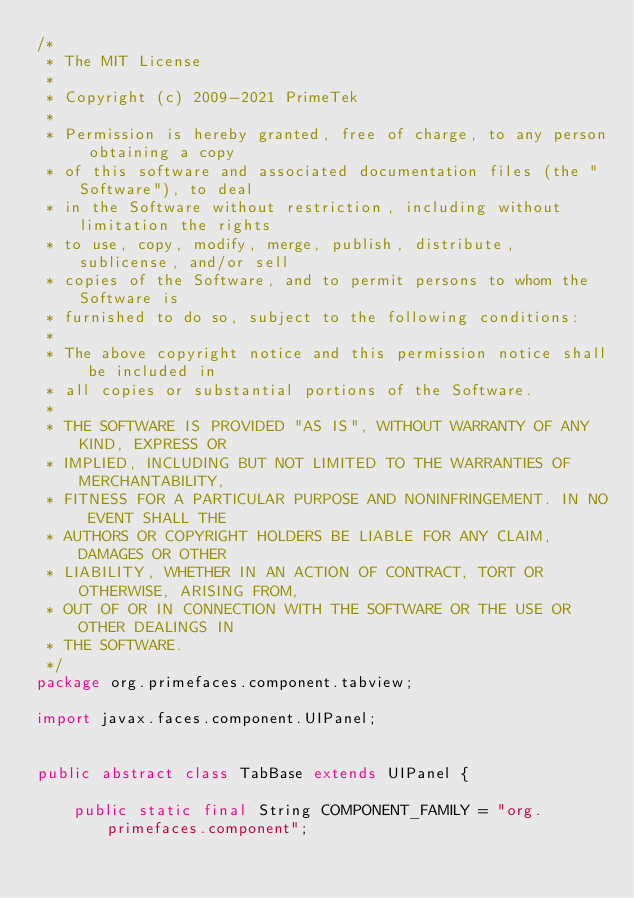<code> <loc_0><loc_0><loc_500><loc_500><_Java_>/*
 * The MIT License
 *
 * Copyright (c) 2009-2021 PrimeTek
 *
 * Permission is hereby granted, free of charge, to any person obtaining a copy
 * of this software and associated documentation files (the "Software"), to deal
 * in the Software without restriction, including without limitation the rights
 * to use, copy, modify, merge, publish, distribute, sublicense, and/or sell
 * copies of the Software, and to permit persons to whom the Software is
 * furnished to do so, subject to the following conditions:
 *
 * The above copyright notice and this permission notice shall be included in
 * all copies or substantial portions of the Software.
 *
 * THE SOFTWARE IS PROVIDED "AS IS", WITHOUT WARRANTY OF ANY KIND, EXPRESS OR
 * IMPLIED, INCLUDING BUT NOT LIMITED TO THE WARRANTIES OF MERCHANTABILITY,
 * FITNESS FOR A PARTICULAR PURPOSE AND NONINFRINGEMENT. IN NO EVENT SHALL THE
 * AUTHORS OR COPYRIGHT HOLDERS BE LIABLE FOR ANY CLAIM, DAMAGES OR OTHER
 * LIABILITY, WHETHER IN AN ACTION OF CONTRACT, TORT OR OTHERWISE, ARISING FROM,
 * OUT OF OR IN CONNECTION WITH THE SOFTWARE OR THE USE OR OTHER DEALINGS IN
 * THE SOFTWARE.
 */
package org.primefaces.component.tabview;

import javax.faces.component.UIPanel;


public abstract class TabBase extends UIPanel {

    public static final String COMPONENT_FAMILY = "org.primefaces.component";
</code> 